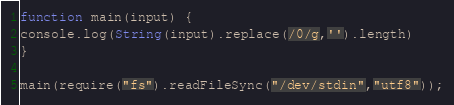Convert code to text. <code><loc_0><loc_0><loc_500><loc_500><_JavaScript_>function main(input) {
console.log(String(input).replace(/0/g,'').length)
}
 
main(require("fs").readFileSync("/dev/stdin","utf8"));</code> 